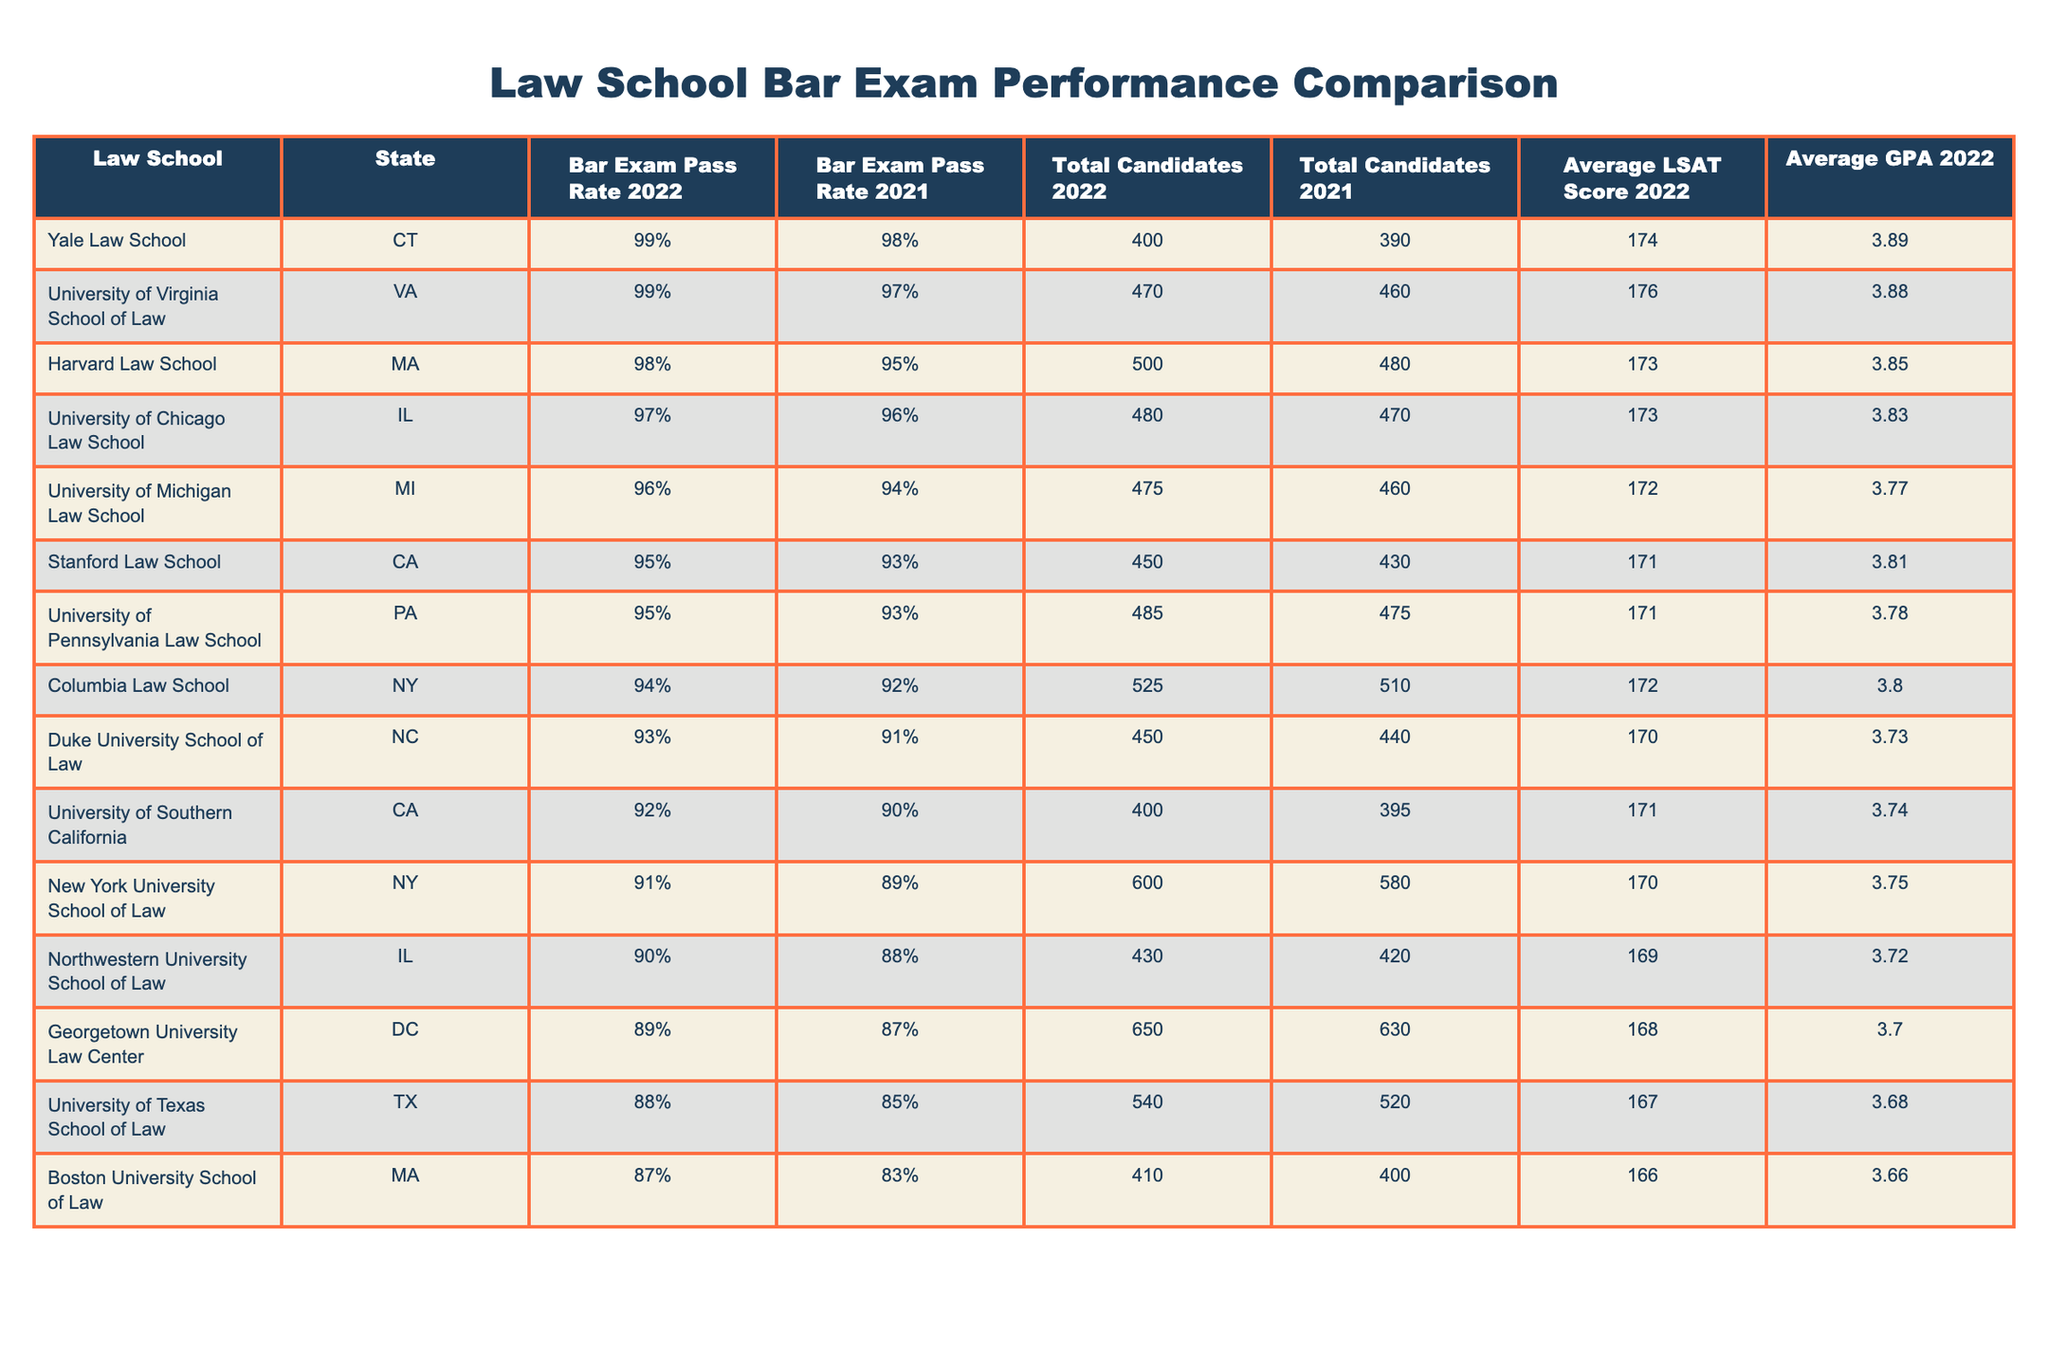What is the bar exam pass rate for Harvard Law School in 2022? The table shows that the bar exam pass rate for Harvard Law School in 2022 is 98%.
Answer: 98% Which law school had the lowest bar exam pass rate in 2021? By examining the pass rates for 2021, Georgetown University Law Center has the lowest pass rate at 87%.
Answer: Georgetown University Law Center What is the total number of candidates for Yale Law School in 2022? The table indicates that Yale Law School had a total of 400 candidates in 2022.
Answer: 400 What is the difference in bar exam pass rates between Duke University School of Law for 2022 and 2021? Duke University School of Law had a pass rate of 93% in 2022 and 91% in 2021. The difference is 93% - 91% = 2%.
Answer: 2% What is the average LSAT score of the top three law schools by pass rate in 2022? The top three law schools by pass rate in 2022 are Yale (LSAT 174), Harvard (LSAT 173), and University of Virginia (LSAT 176). The average LSAT score is (174 + 173 + 176) / 3 = 174.33.
Answer: 174.33 Is the average GPA of Northwestern University School of Law higher than Duke University School of Law in 2022? Northwestern's average GPA is 3.72, and Duke's average GPA is 3.73; therefore, Northwestern's average GPA is lower than Duke's.
Answer: No Which law school had the highest number of total candidates in 2022? The table shows that New York University School of Law had the highest number of total candidates in 2022 with 600 candidates.
Answer: New York University School of Law What is the median bar exam pass rate for all law schools in 2022? Ordering the 2022 pass rates: 88%, 89%, 90%, 91%, 92%, 93%, 94%, 95%, 96%, 97%, 98%, 99%, the median is the average of the 6th and 7th values (93% and 94%), which is (93 + 94) / 2 = 93.5%.
Answer: 93.5% What percentage increase in bar exam pass rate did the University of Southern California experience from 2021 to 2022? USC's pass rates are 90% in 2021 and 92% in 2022; the increase is (92% - 90%) / 90% * 100% = 2.22%.
Answer: 2.22% Is it true that all law schools with bar pass rates above 95% in 2022 had average LSAT scores of at least 171? The schools with pass rates above 95% are Harvard (173), Yale (174), University of Chicago (173), and University of Virginia (176), all of which have LSAT scores above 171. Therefore, it is true.
Answer: Yes 